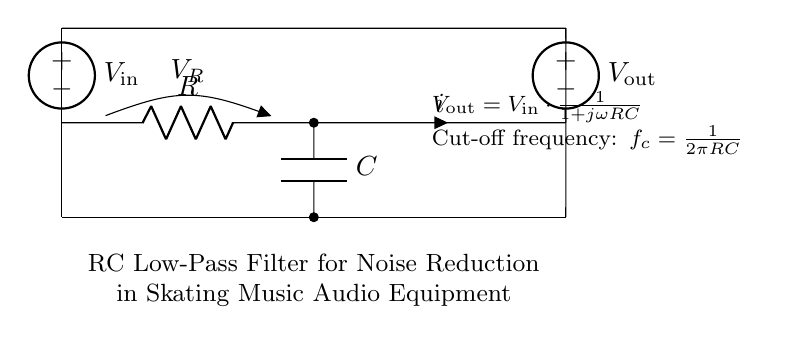What is the input voltage source in the circuit? The input voltage source is denoted as V_in, which is represented by the symbol at the left side of the circuit diagram.
Answer: V_in What is the output voltage in this RC filter? The output voltage is given as V_out, which is indicated at the right side of the circuit diagram.
Answer: V_out What components are used in the circuit? The circuit consists of a resistor (R) and a capacitor (C), which are clearly labeled in the diagram.
Answer: Resistor and capacitor What is the cut-off frequency formula for the circuit? The cut-off frequency, denoted as f_c, is given by the formula f_c = 1 / (2 * pi * R * C), which is provided in the notes of the diagram.
Answer: 1 / (2 * pi * R * C) How does the output voltage relate to the input voltage? The relationship is described by the equation V_out = V_in * (1 / (1 + jωRC)), indicating how the output is a function of the input, resistance, capacitance, and frequency.
Answer: V_out = V_in * (1 / (1 + jωRC)) What is the role of the capacitor in this circuit? The capacitor is used to block direct current (DC) and allow alternating current (AC) signals to pass, acting as a filter for high-frequency noise in the audio signal.
Answer: To filter high-frequency noise What is the significance of the resistor in the RC filter? The resistor controls the time constant of the filter, determining how quickly the capacitor charges and discharges, thus influencing the cut-off frequency and the overall response of the filter.
Answer: To control time constant 